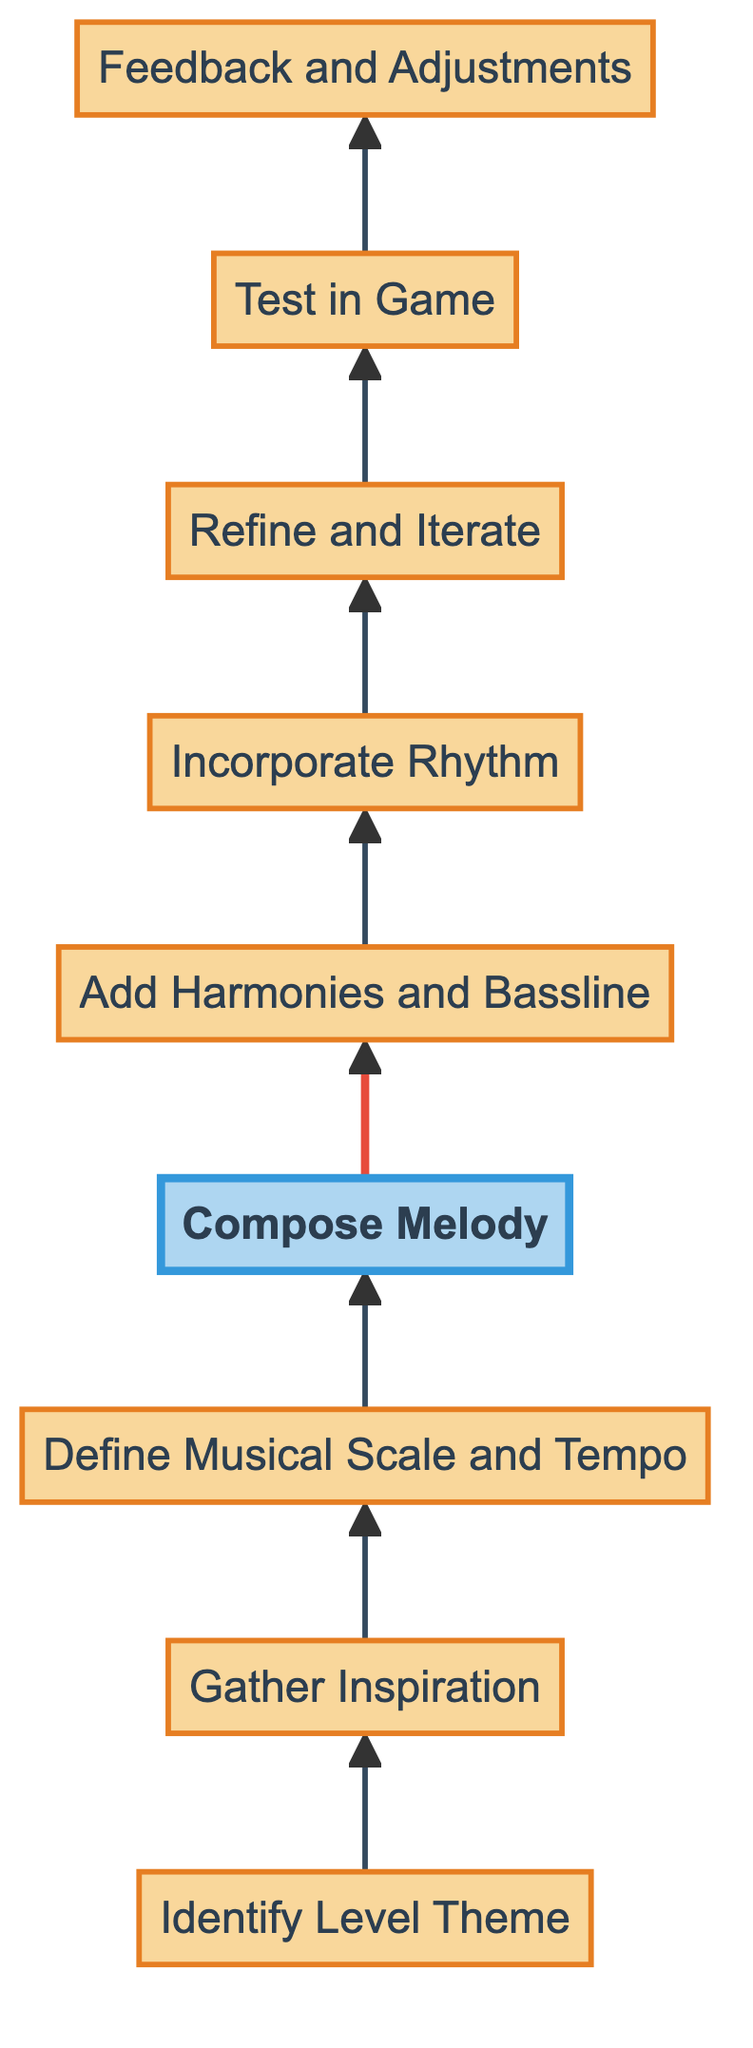What is the first step in the process? The first node in the flow chart is "Identify Level Theme". This is indicated as the starting point of the diagram with an arrow leading up to the next step.
Answer: Identify Level Theme How many total steps are there in the diagram? By counting the nodes in the diagram, from "Identify Level Theme" to "Feedback and Adjustments," there are a total of nine steps.
Answer: 9 Which step involves creating the melody? The node labeled "Compose Melody" is where the main melody line is created, as indicated in the chart. This is the fourth step in the flow.
Answer: Compose Melody What is the last step in the process? The final node in the flow chart is "Feedback and Adjustments," which indicates the last action taken before the process concludes.
Answer: Feedback and Adjustments What step comes before adding rhythm? The step that precedes "Incorporate Rhythm" is "Add Harmonies and Bassline." This shows the order of operations based on the arrows leading upwards in the chart.
Answer: Add Harmonies and Bassline Which two steps follow "Gather Inspiration"? The two subsequent steps that follow "Gather Inspiration" are "Define Musical Scale and Tempo" and "Compose Melody." This is shown by the arrows leading upwards from "Gather Inspiration."
Answer: Define Musical Scale and Tempo, Compose Melody Which step is highlighted in the diagram? The step "Compose Melody" is highlighted in the diagram, indicating its significance among the other nodes. The highlighting is emphasized with a different color and stroke width.
Answer: Compose Melody What is the relationship between "Test in Game" and "Feedback and Adjustments"? "Test in Game" directly leads to "Feedback and Adjustments" as indicated by the arrow connecting these two steps, showing that testing leads to feedback.
Answer: Directly leads What node represents the gathering of playtester feedback? The node named "Feedback and Adjustments" represents the gathering of playtester feedback and implementing changes based on it, as shown in the flow.
Answer: Feedback and Adjustments 